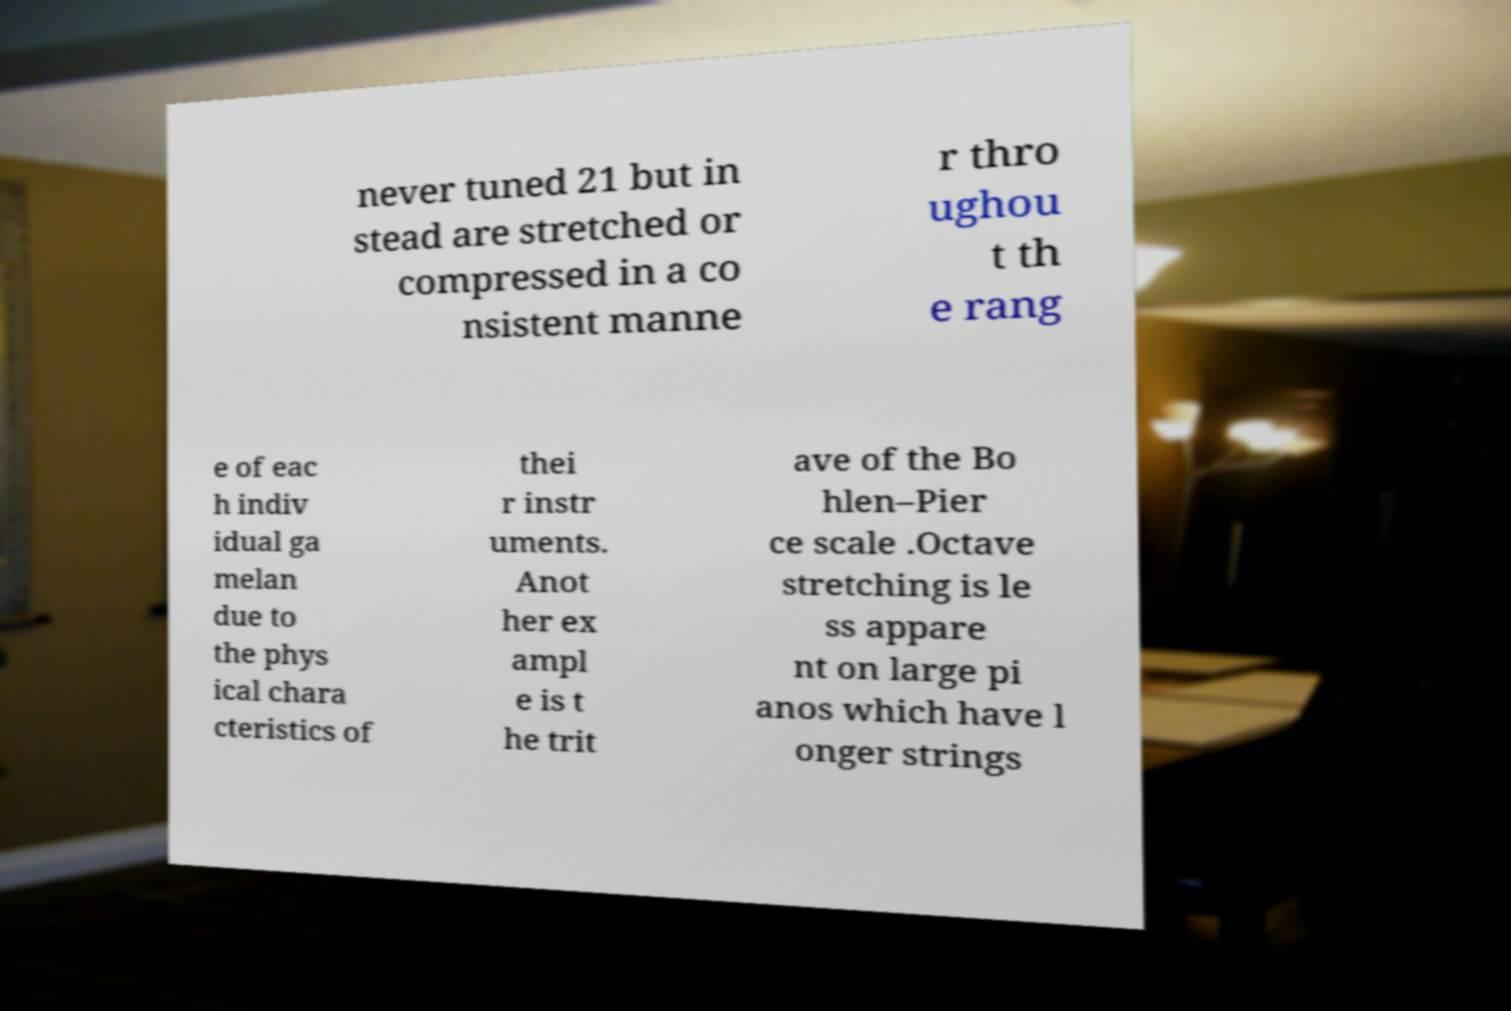Please read and relay the text visible in this image. What does it say? never tuned 21 but in stead are stretched or compressed in a co nsistent manne r thro ughou t th e rang e of eac h indiv idual ga melan due to the phys ical chara cteristics of thei r instr uments. Anot her ex ampl e is t he trit ave of the Bo hlen–Pier ce scale .Octave stretching is le ss appare nt on large pi anos which have l onger strings 